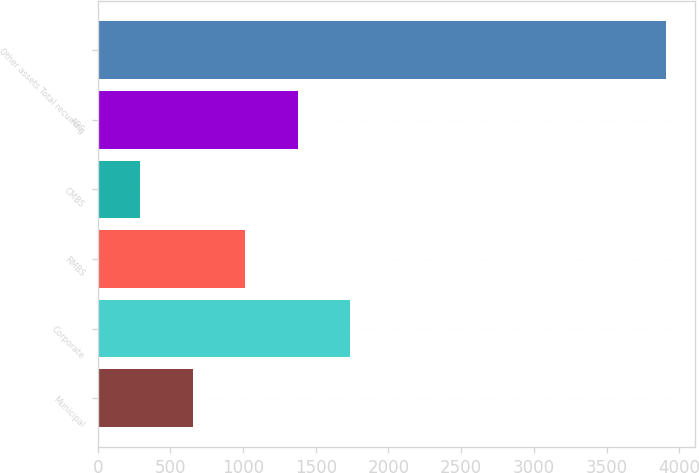Convert chart to OTSL. <chart><loc_0><loc_0><loc_500><loc_500><bar_chart><fcel>Municipal<fcel>Corporate<fcel>RMBS<fcel>CMBS<fcel>ABS<fcel>Other assets Total recurring<nl><fcel>652.9<fcel>1738.6<fcel>1014.8<fcel>291<fcel>1376.7<fcel>3910<nl></chart> 